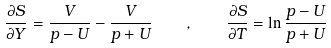<formula> <loc_0><loc_0><loc_500><loc_500>\frac { \partial S } { \partial Y } = \frac { V } { p - U } - \frac { V } { p + U } \quad , \quad \frac { \partial S } { \partial T } = \ln \frac { p - U } { p + U }</formula> 